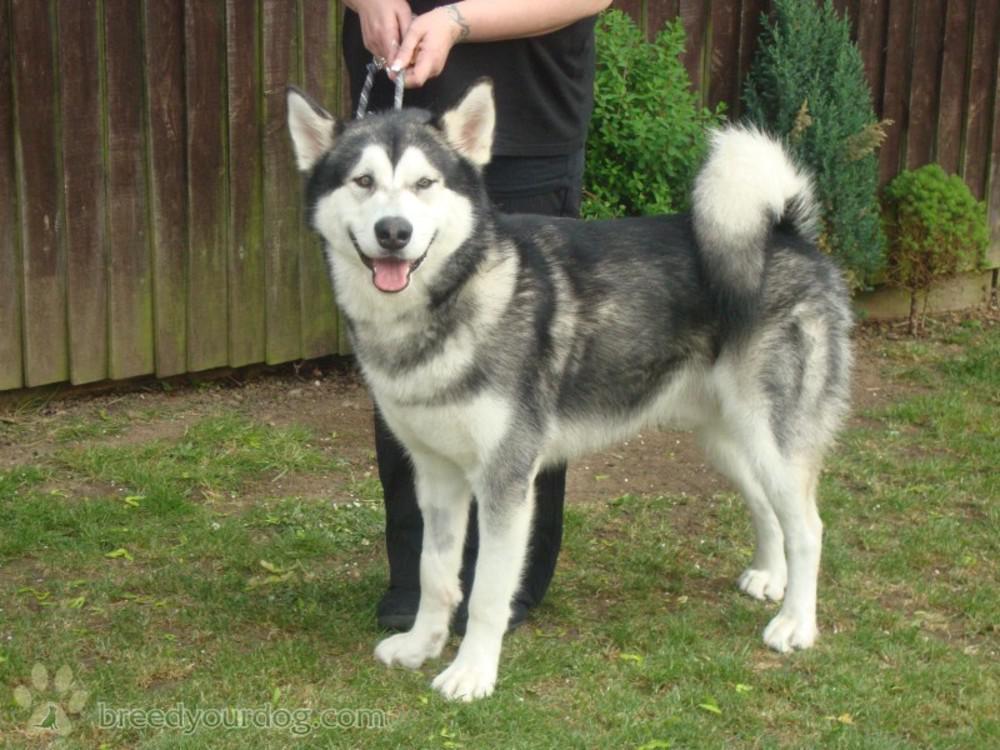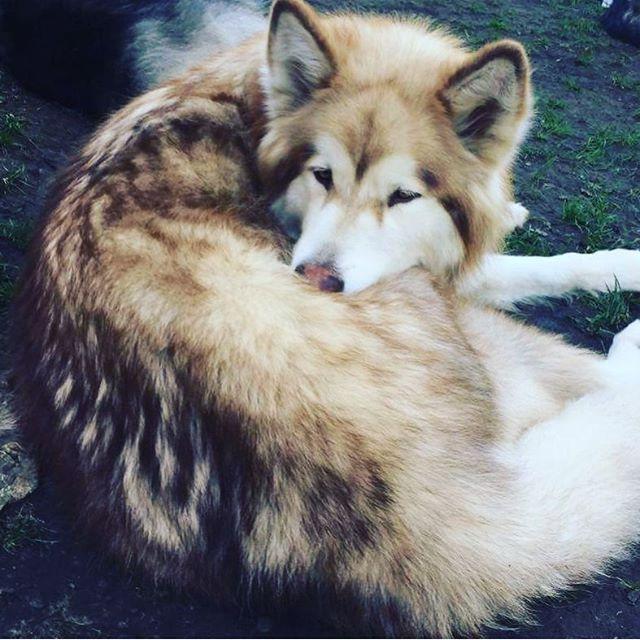The first image is the image on the left, the second image is the image on the right. For the images shown, is this caption "A person wearing black is beside a black-and-white husky in the left image, and the right image shows a reclining dog with white and brown fur." true? Answer yes or no. Yes. The first image is the image on the left, the second image is the image on the right. Given the left and right images, does the statement "The dog in the image on the left is standing up outside." hold true? Answer yes or no. Yes. 